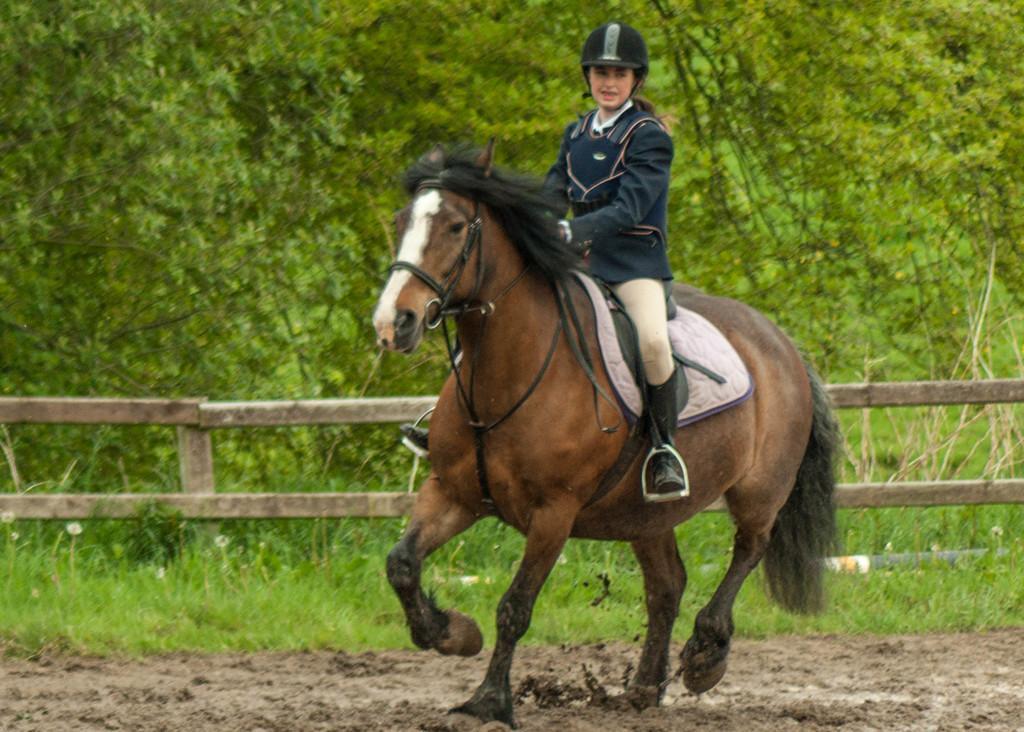Describe this image in one or two sentences. This picture is clicked outside. In the center there is a person wearing helmet and riding a horse. In the foreground we can see the mud, green grass, fence and some plants. In the background we can see the trees. 